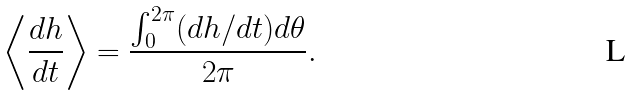<formula> <loc_0><loc_0><loc_500><loc_500>\left < \frac { d h } { d t } \right > = \frac { \int ^ { 2 \pi } _ { 0 } ( d h / d t ) d \theta } { 2 \pi } .</formula> 